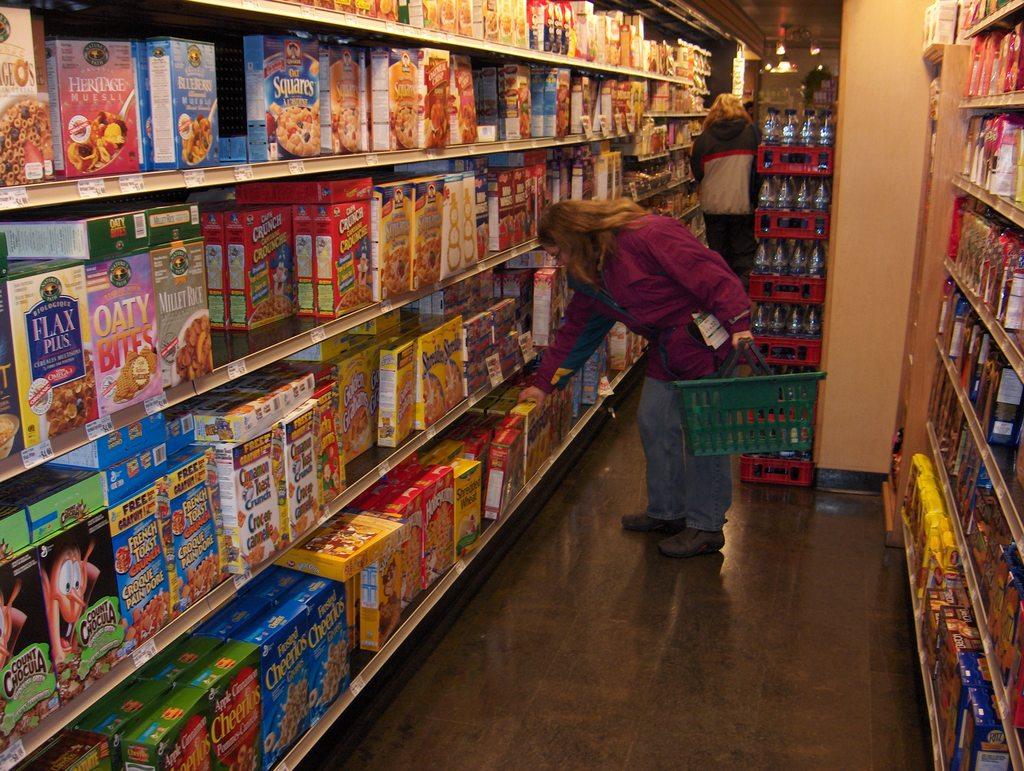What's the name of the cereal on the bottom shelf in far left?
Keep it short and to the point. Cheerios. Is that cheerios cereal on the bottom left shelf?
Offer a very short reply. Yes. 